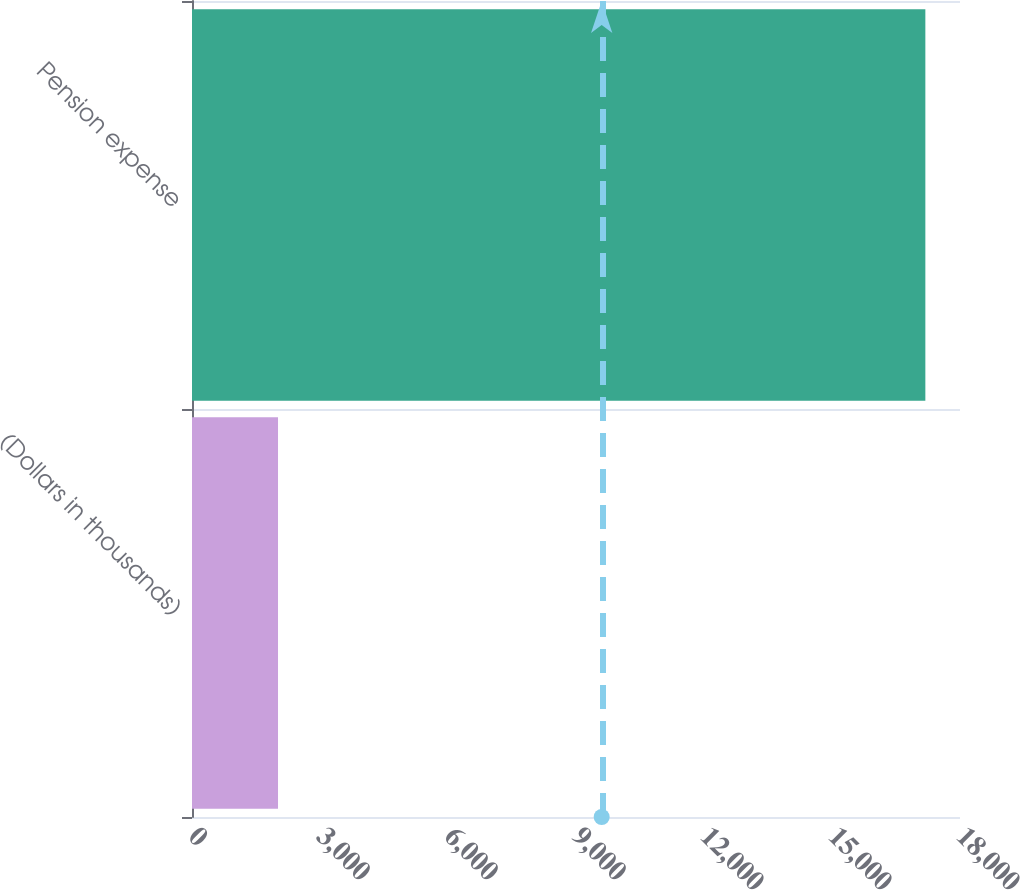<chart> <loc_0><loc_0><loc_500><loc_500><bar_chart><fcel>(Dollars in thousands)<fcel>Pension expense<nl><fcel>2016<fcel>17188<nl></chart> 